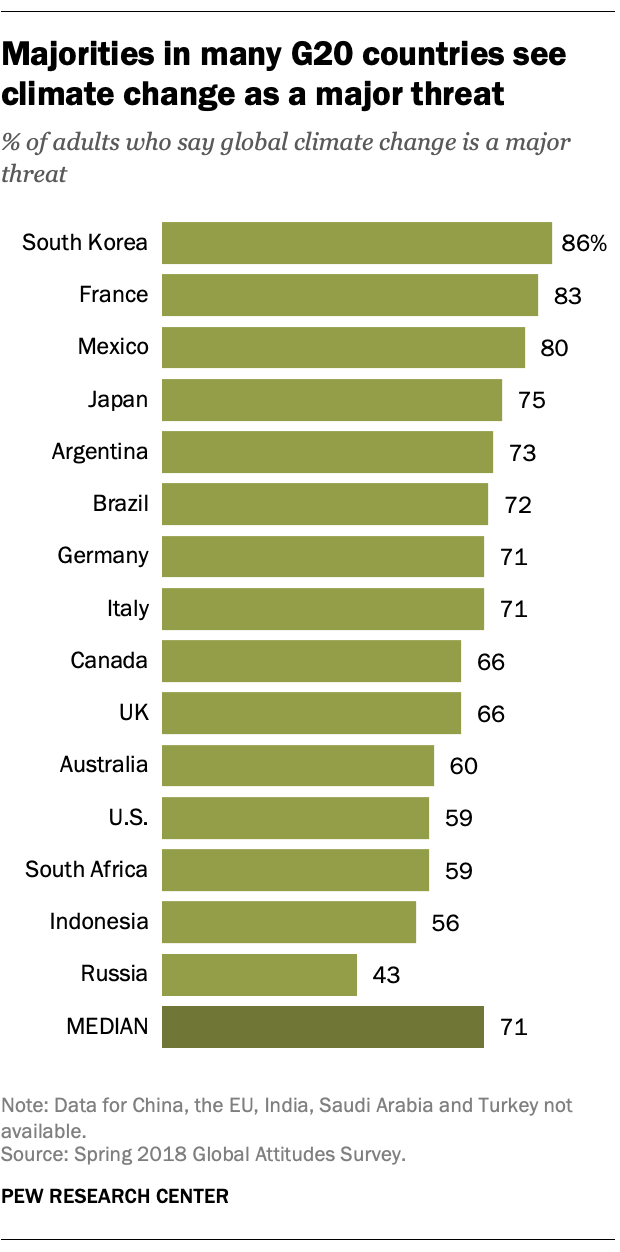Specify some key components in this picture. The value of green bars in Argentina is 73. The occurrence of the bar with value 71 is the same as the occurrence of the bar with value 66. 